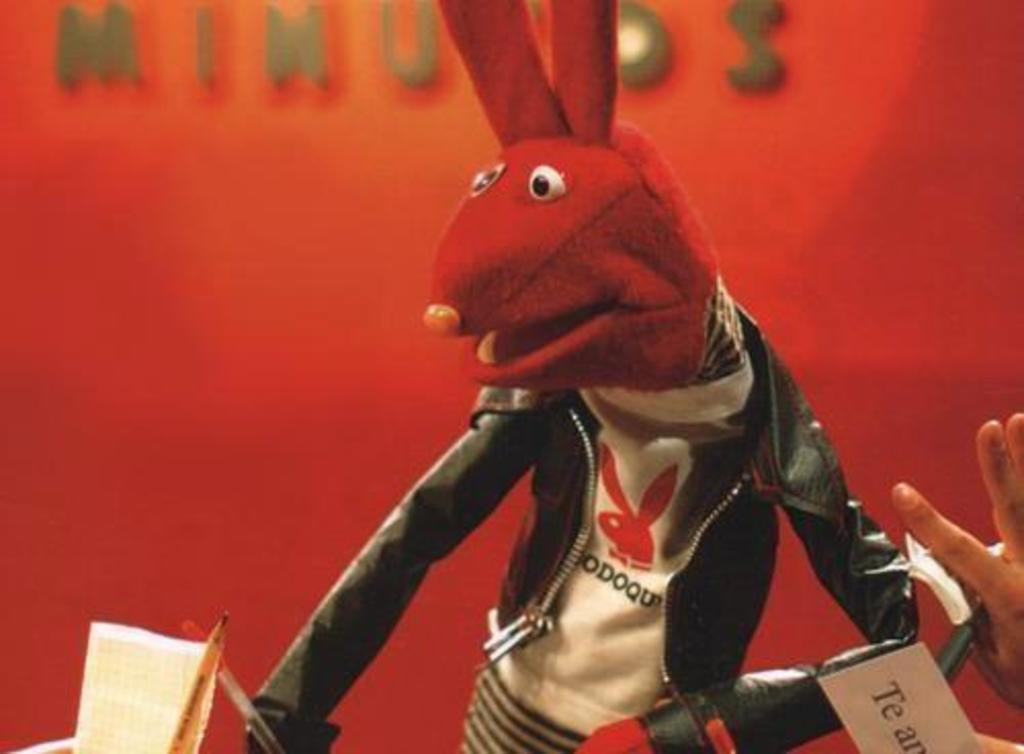What is the main subject in the center of the image? There is a cartoon in the center of the image. What object is located at the bottom of the image? There is a mic at the bottom of the image. What can be seen in the background of the image? There is a wall and a board visible in the background of the image. What type of coach is present in the image? There is no coach present in the image. What act is being performed by the cartoon in the image? The image does not depict any act being performed by the cartoon; it is a static image. 